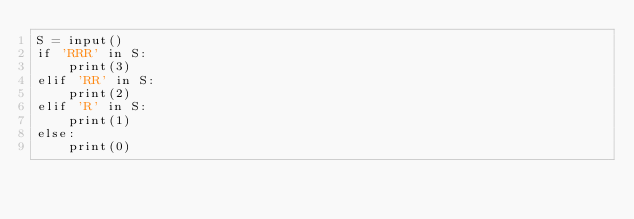<code> <loc_0><loc_0><loc_500><loc_500><_Python_>S = input()
if 'RRR' in S:
    print(3)
elif 'RR' in S:
    print(2)
elif 'R' in S:
    print(1)
else:
    print(0)
</code> 